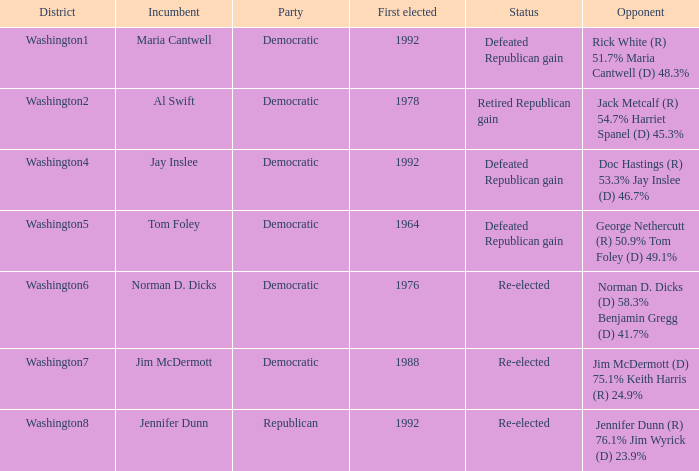Help me parse the entirety of this table. {'header': ['District', 'Incumbent', 'Party', 'First elected', 'Status', 'Opponent'], 'rows': [['Washington1', 'Maria Cantwell', 'Democratic', '1992', 'Defeated Republican gain', 'Rick White (R) 51.7% Maria Cantwell (D) 48.3%'], ['Washington2', 'Al Swift', 'Democratic', '1978', 'Retired Republican gain', 'Jack Metcalf (R) 54.7% Harriet Spanel (D) 45.3%'], ['Washington4', 'Jay Inslee', 'Democratic', '1992', 'Defeated Republican gain', 'Doc Hastings (R) 53.3% Jay Inslee (D) 46.7%'], ['Washington5', 'Tom Foley', 'Democratic', '1964', 'Defeated Republican gain', 'George Nethercutt (R) 50.9% Tom Foley (D) 49.1%'], ['Washington6', 'Norman D. Dicks', 'Democratic', '1976', 'Re-elected', 'Norman D. Dicks (D) 58.3% Benjamin Gregg (D) 41.7%'], ['Washington7', 'Jim McDermott', 'Democratic', '1988', 'Re-elected', 'Jim McDermott (D) 75.1% Keith Harris (R) 24.9%'], ['Washington8', 'Jennifer Dunn', 'Republican', '1992', 'Re-elected', 'Jennifer Dunn (R) 76.1% Jim Wyrick (D) 23.9%']]} 3% jay inslee (d) 4 Defeated Republican gain. 